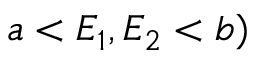<formula> <loc_0><loc_0><loc_500><loc_500>a < E _ { 1 } , E _ { 2 } < b )</formula> 